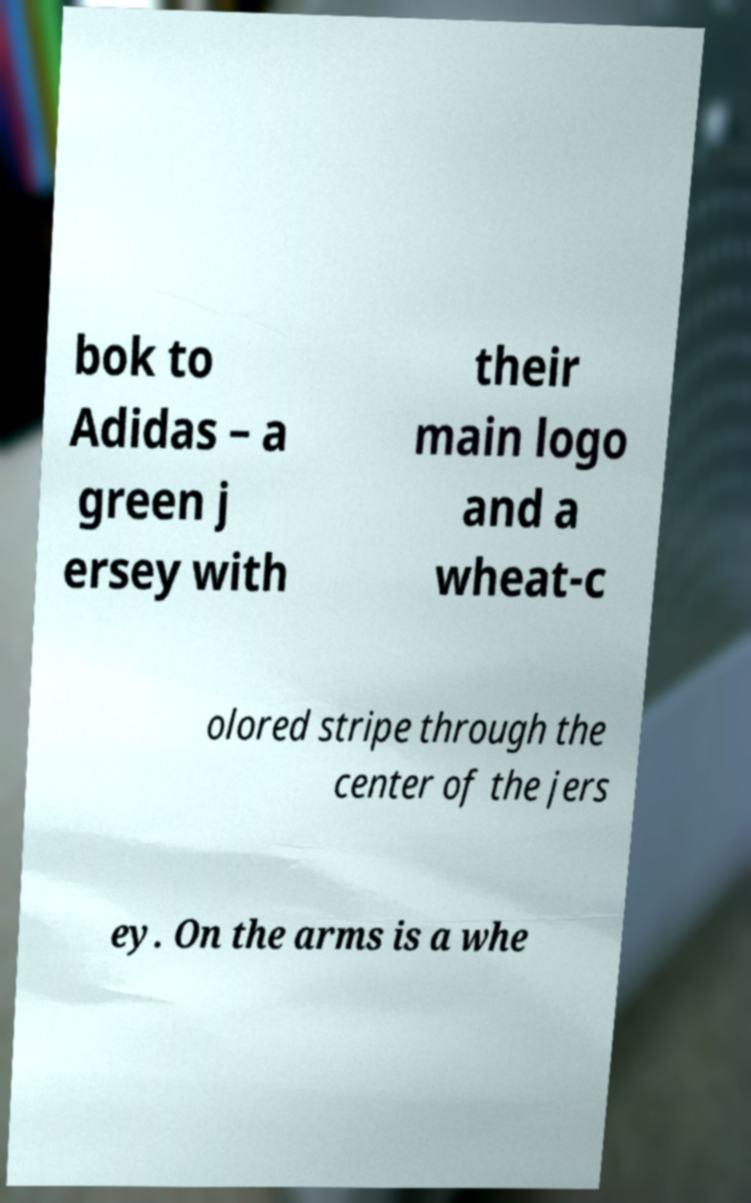For documentation purposes, I need the text within this image transcribed. Could you provide that? bok to Adidas – a green j ersey with their main logo and a wheat-c olored stripe through the center of the jers ey. On the arms is a whe 